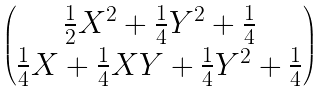<formula> <loc_0><loc_0><loc_500><loc_500>\begin{pmatrix} \frac { 1 } { 2 } X ^ { 2 } + \frac { 1 } { 4 } Y ^ { 2 } + \frac { 1 } { 4 } \\ \frac { 1 } { 4 } X + \frac { 1 } { 4 } X Y + \frac { 1 } { 4 } Y ^ { 2 } + \frac { 1 } { 4 } \end{pmatrix}</formula> 